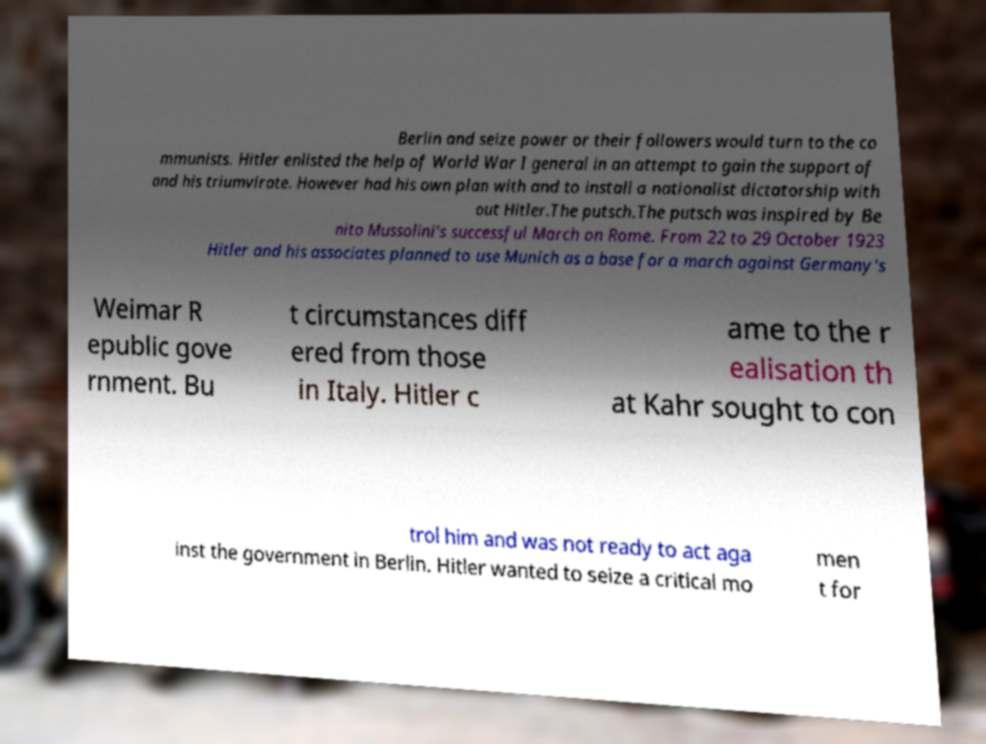Could you extract and type out the text from this image? Berlin and seize power or their followers would turn to the co mmunists. Hitler enlisted the help of World War I general in an attempt to gain the support of and his triumvirate. However had his own plan with and to install a nationalist dictatorship with out Hitler.The putsch.The putsch was inspired by Be nito Mussolini's successful March on Rome. From 22 to 29 October 1923 Hitler and his associates planned to use Munich as a base for a march against Germany's Weimar R epublic gove rnment. Bu t circumstances diff ered from those in Italy. Hitler c ame to the r ealisation th at Kahr sought to con trol him and was not ready to act aga inst the government in Berlin. Hitler wanted to seize a critical mo men t for 